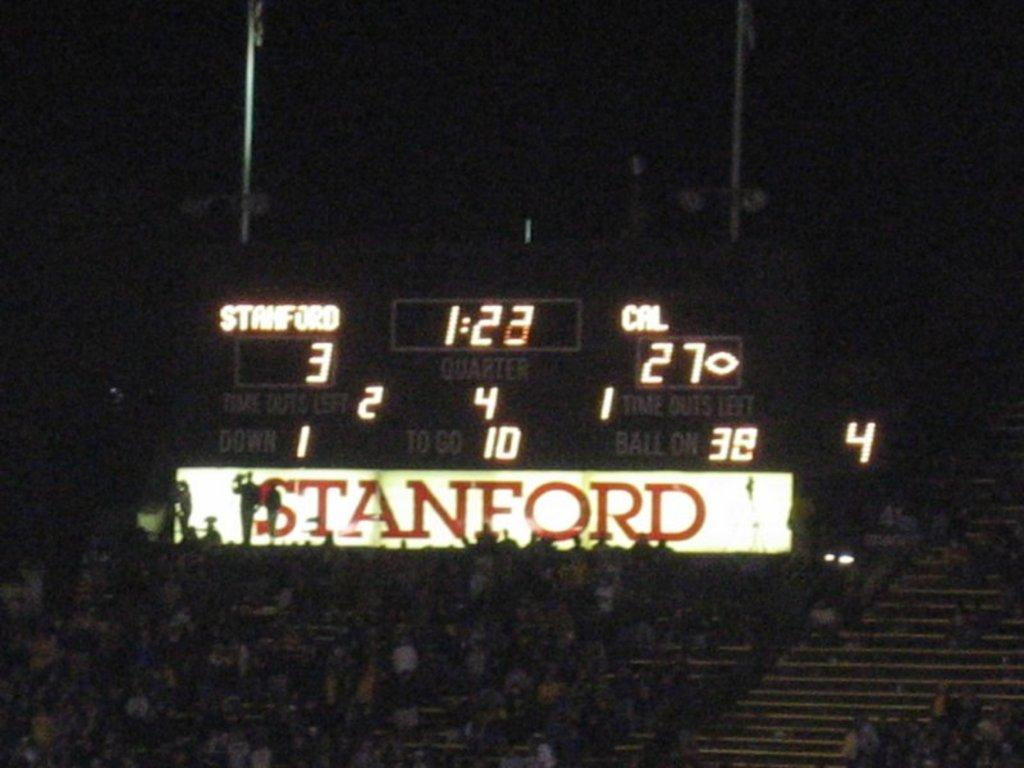Provide a one-sentence caption for the provided image. Scoreboard keeping track of the game between Stanford and CAL. 